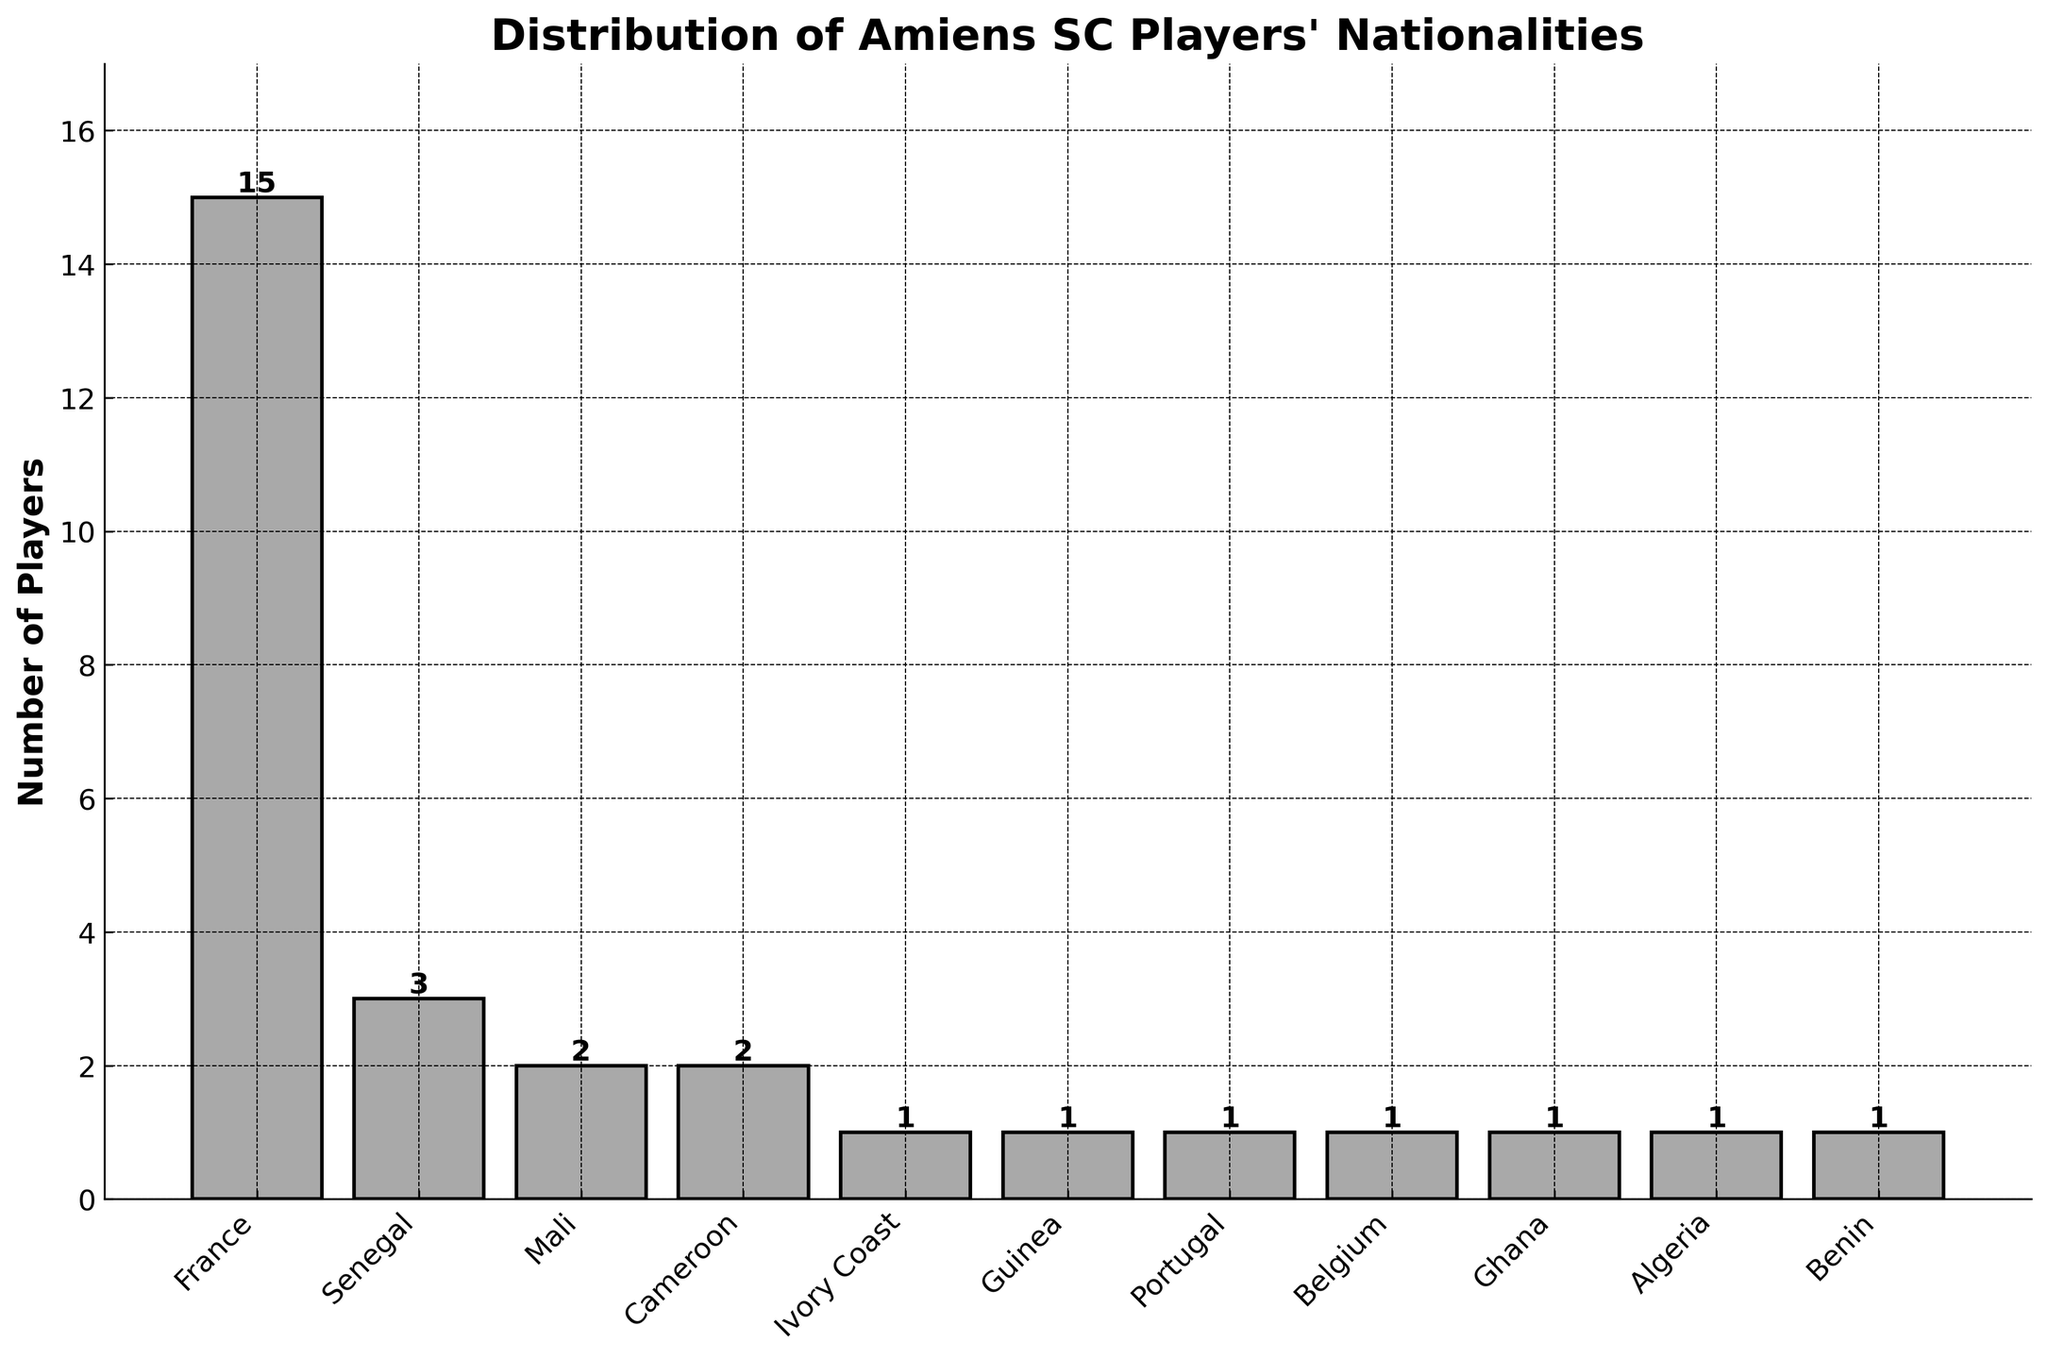How many players in total are from African countries? Add the number of players from Senegal (3), Mali (2), Cameroon (2), Ivory Coast (1), Guinea (1), Ghana (1), Algeria (1), and Benin (1). The sum is 3 + 2 + 2 + 1 + 1 + 1 + 1 + 1 = 12.
Answer: 12 Which nationality has the most players in the Amiens SC squad? Look for the tallest bar in the chart, which represents France with 15 players.
Answer: France How many more French players are there compared to Senegalese players? Subtract the number of Senegalese players (3) from the number of French players (15). The difference is 15 - 3 = 12.
Answer: 12 What is the difference in the number of players between the nationalities with the highest and the lowest representation? The highest is France with 15 players, and the lowest are Ivory Coast, Guinea, Portugal, Belgium, Ghana, Algeria, and Benin with 1 player each. The difference is 15 - 1 = 14.
Answer: 14 If you grouped players by African and non-African nationalities, what would be the count for each group? African countries represented are Senegal (3), Mali (2), Cameroon (2), Ivory Coast (1), Guinea (1), Ghana (1), Algeria (1), and Benin (1), totalling 12. Non-African countries represented are France (15), Portugal (1), and Belgium (1), totalling 17.
Answer: 12 African, 17 non-African Are there more players from Senegal or from the combined countries of Mali and Cameroon? Add the number of players from Mali (2) and Cameroon (2) to compare with the number of players from Senegal (3). The sum is 2 + 2 = 4, which is greater than 3.
Answer: Mali and Cameroon Which two nationalities have exactly the same number of players? Find the bars with the same height. Mali and Cameroon both have 2 players each.
Answer: Mali and Cameroon What is the combined total of players from Belgium and Portugal? Add the number of players from Belgium (1) and Portugal (1). The sum is 1 + 1 = 2.
Answer: 2 Which nationalities have only one player each, and how many such nationalities are there? Look for bars representing 1 player. These nationalities are Ivory Coast, Guinea, Portugal, Belgium, Ghana, Algeria, and Benin. There are 7 such nationalities.
Answer: 7 nationalities What is the average number of players per nationality if you exclude France? Exclude France and add the number of players from the remaining nationalities: 3 + 2 + 2 + 1 + 1 + 1 + 1 + 1 + 1 + 1 = 14. There are 10 nationalities excluding France. The average is 14 / 10 = 1.4.
Answer: 1.4 